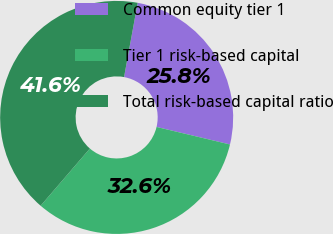<chart> <loc_0><loc_0><loc_500><loc_500><pie_chart><fcel>Common equity tier 1<fcel>Tier 1 risk-based capital<fcel>Total risk-based capital ratio<nl><fcel>25.84%<fcel>32.58%<fcel>41.57%<nl></chart> 